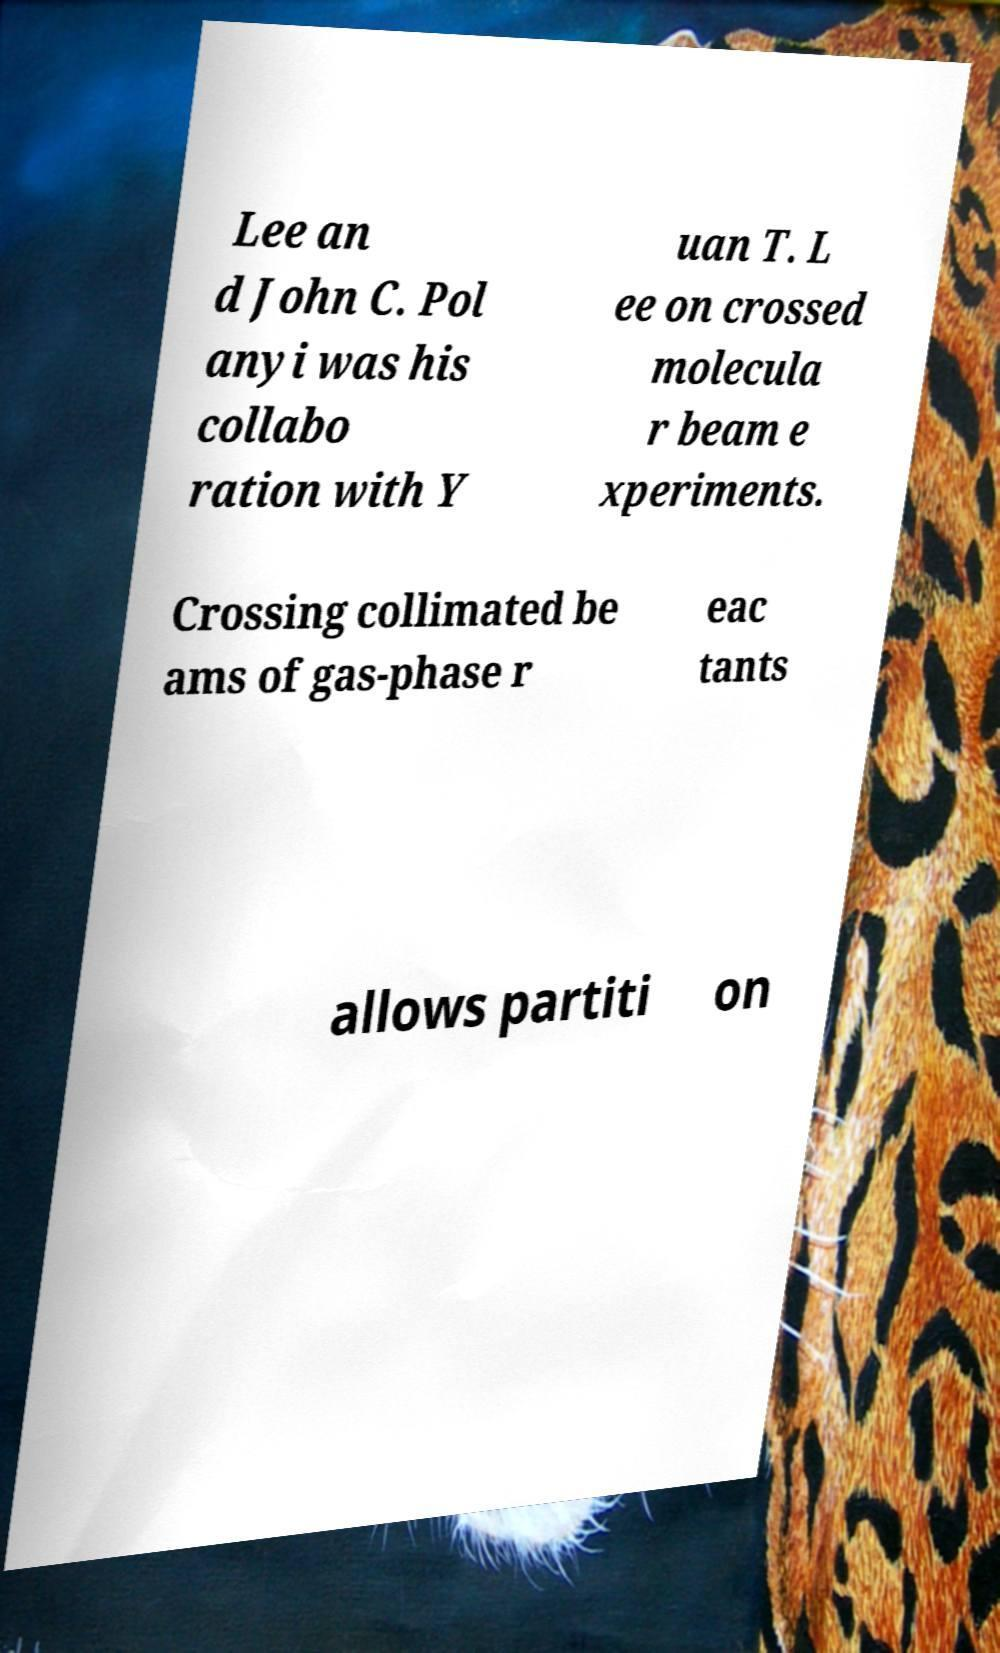I need the written content from this picture converted into text. Can you do that? Lee an d John C. Pol anyi was his collabo ration with Y uan T. L ee on crossed molecula r beam e xperiments. Crossing collimated be ams of gas-phase r eac tants allows partiti on 